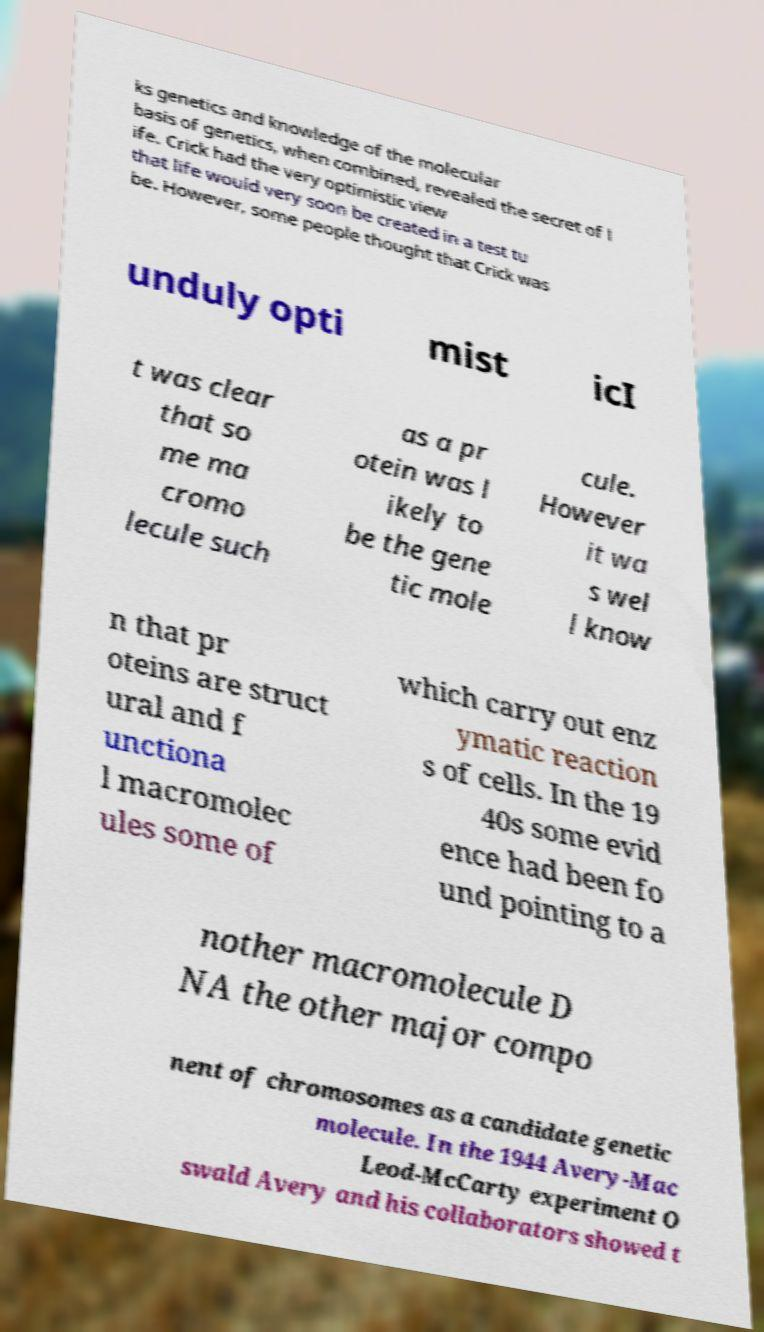Can you accurately transcribe the text from the provided image for me? ks genetics and knowledge of the molecular basis of genetics, when combined, revealed the secret of l ife. Crick had the very optimistic view that life would very soon be created in a test tu be. However, some people thought that Crick was unduly opti mist icI t was clear that so me ma cromo lecule such as a pr otein was l ikely to be the gene tic mole cule. However it wa s wel l know n that pr oteins are struct ural and f unctiona l macromolec ules some of which carry out enz ymatic reaction s of cells. In the 19 40s some evid ence had been fo und pointing to a nother macromolecule D NA the other major compo nent of chromosomes as a candidate genetic molecule. In the 1944 Avery-Mac Leod-McCarty experiment O swald Avery and his collaborators showed t 